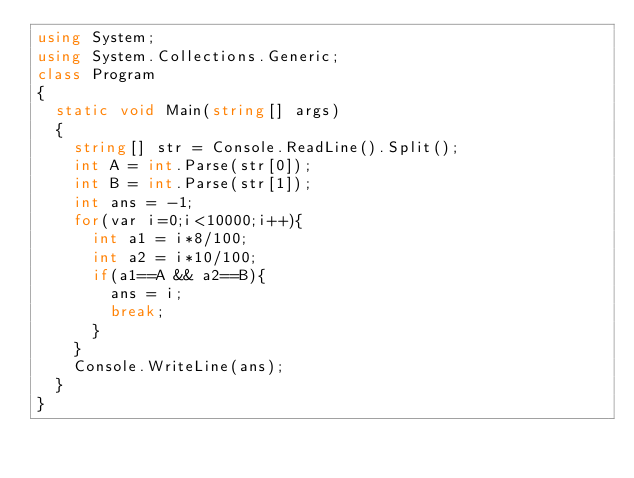Convert code to text. <code><loc_0><loc_0><loc_500><loc_500><_C#_>using System;
using System.Collections.Generic;
class Program
{
	static void Main(string[] args)
	{
		string[] str = Console.ReadLine().Split();
		int A = int.Parse(str[0]);
		int B = int.Parse(str[1]);
		int ans = -1;
		for(var i=0;i<10000;i++){
			int a1 = i*8/100;
			int a2 = i*10/100;
			if(a1==A && a2==B){
				ans = i;
				break;
			}
		}
		Console.WriteLine(ans);
	}
}</code> 